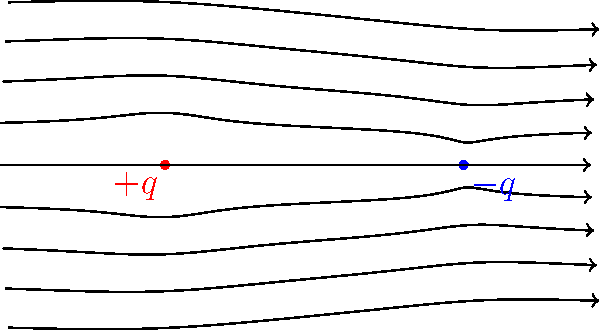As a project manager overseeing an e-learning platform, you're reviewing a physics module on electric fields. The IT specialist has integrated the above image into the platform. What can you conclude about the relative strengths of the two charges based on the electric field lines shown? To interpret the electric field lines between two charged particles, we need to consider the following steps:

1. Identify the charges: The left particle (red) is positively charged ($+q$), and the right particle (blue) is negatively charged ($-q$).

2. Observe the direction of the field lines: 
   - Field lines originate from positive charges and terminate on negative charges.
   - In this diagram, lines start from the left (+q) and end on the right (-q).

3. Analyze the density and symmetry of the field lines:
   - The field lines appear to be symmetrical around the central axis between the charges.
   - The density of field lines entering the negative charge is equal to the density leaving the positive charge.

4. Consider the relationship between charge magnitude and field line density:
   - The number of field lines associated with a charge is proportional to the magnitude of the charge.
   - Equal density of field lines near both charges suggests equal magnitudes.

5. Conclusion:
   - The symmetry and equal density of field lines indicate that the charges have equal magnitudes but opposite signs.

This interpretation is consistent with the labeling of charges as $+q$ and $-q$, where $q$ represents the same magnitude for both charges.
Answer: The charges have equal magnitudes but opposite signs. 